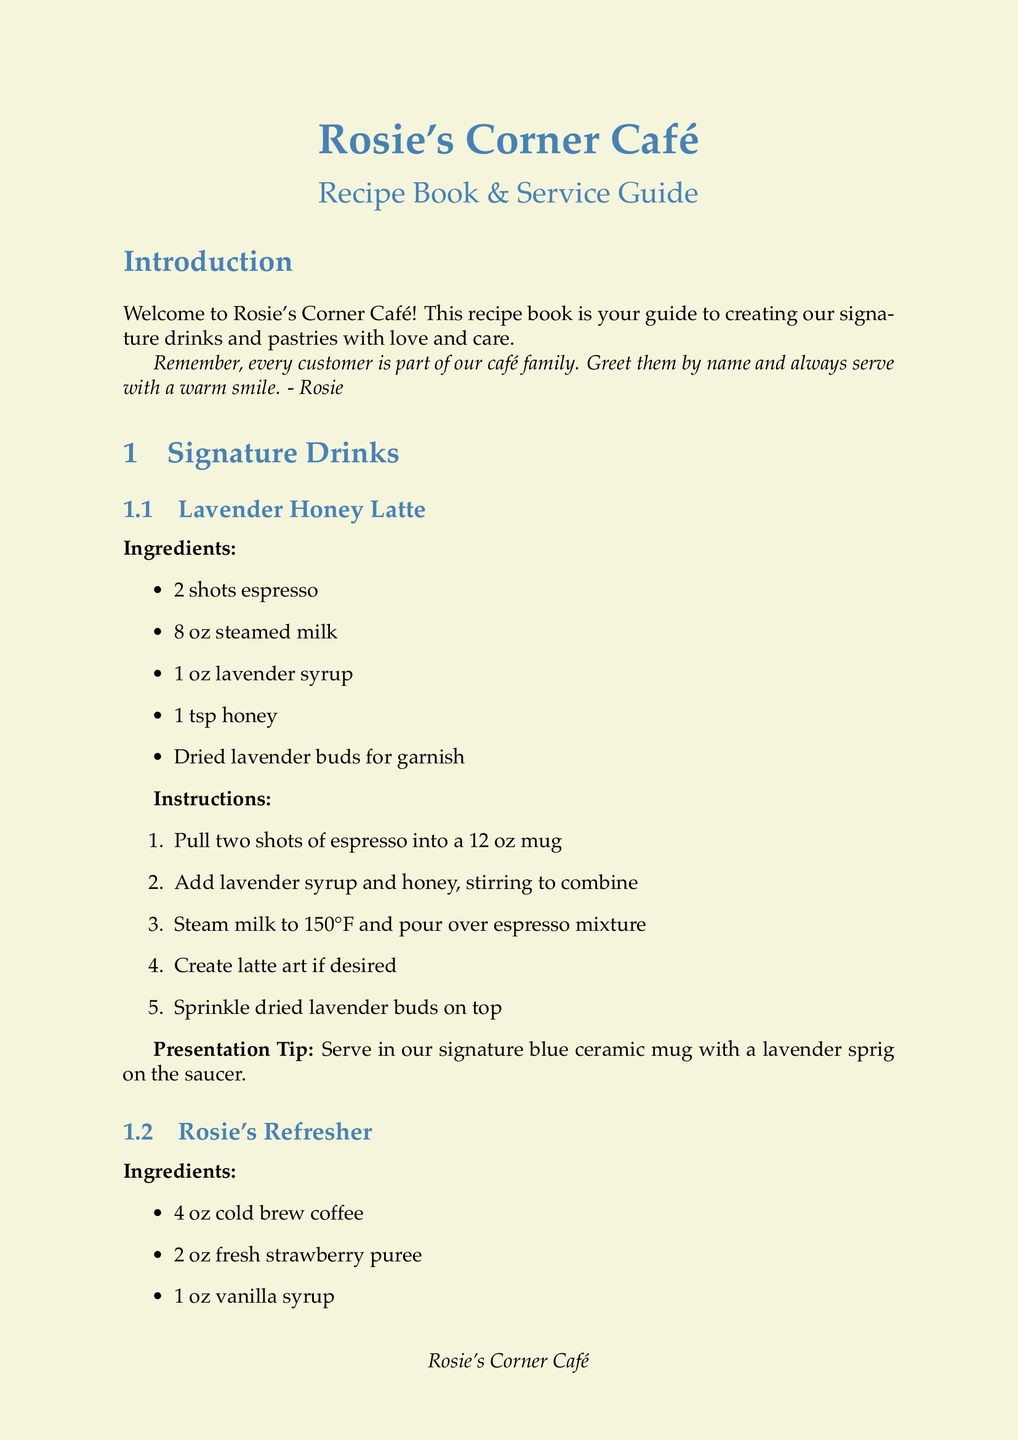What is the name of the first signature drink? The first signature drink listed in the document is "Lavender Honey Latte."
Answer: Lavender Honey Latte How many shots of espresso are used in the Lavender Honey Latte? The recipe specifies that 2 shots of espresso are used in the Lavender Honey Latte.
Answer: 2 shots What is the baking temperature for the Lemon Lavender Scones? The document states that the baking temperature for the Lemon Lavender Scones is 400°F (200°C).
Answer: 400°F (200°C) What ingredient is included for garnish in Rosie's Refresher? The garnish specified in the recipe for Rosie's Refresher is fresh mint leaves.
Answer: Fresh mint leaves What is one of the consistency tips for quality control? One consistency tip is to "Always use the same measuring tools and techniques."
Answer: Use the same measuring tools and techniques How long should the dough rise for the Maple Pecan Cinnamon Rolls? The dough is instructed to rise for 1 hour for the Maple Pecan Cinnamon Rolls.
Answer: 1 hour What should you serve the Lemon Lavender Scones on? The presentation tip states that the scones should be displayed on a rustic wooden board.
Answer: Rustic wooden board How should regular customers be greeted? The document suggests greeting regular customers with "Hello [Name]!" if known.
Answer: Hello [Name]! How is the Lavender Honey Latte served? The presentation tip for the Lavender Honey Latte suggests serving it in a signature blue ceramic mug.
Answer: Signature blue ceramic mug 